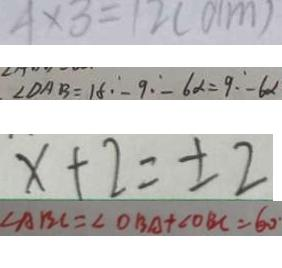<formula> <loc_0><loc_0><loc_500><loc_500>4 \times 3 = 1 2 ( d m ) 
 \angle D A B = 1 8 - 9 - 6 \alpha = 9 \cdot - 6 \alpha 
 x + 2 = \pm 2 
 \angle A B C = \angle O B A + \angle O B C = 6 0 ^ { \circ }</formula> 